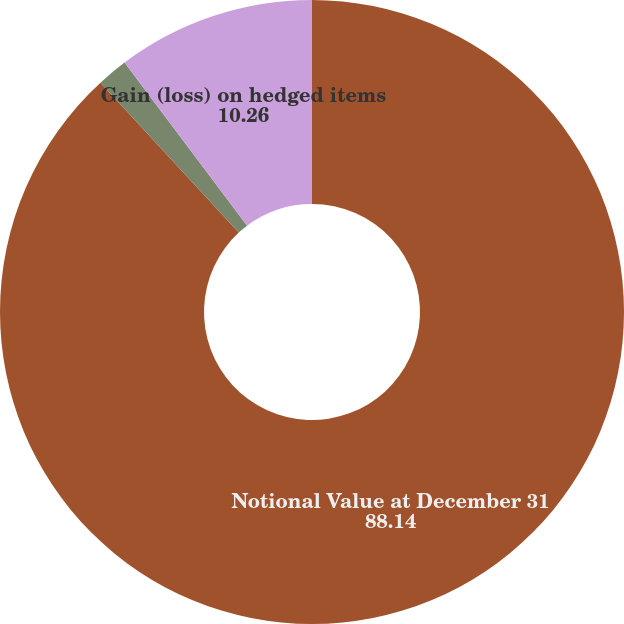Convert chart to OTSL. <chart><loc_0><loc_0><loc_500><loc_500><pie_chart><fcel>Notional Value at December 31<fcel>Gain (loss) on derivative<fcel>Gain (loss) on hedged items<nl><fcel>88.14%<fcel>1.6%<fcel>10.26%<nl></chart> 